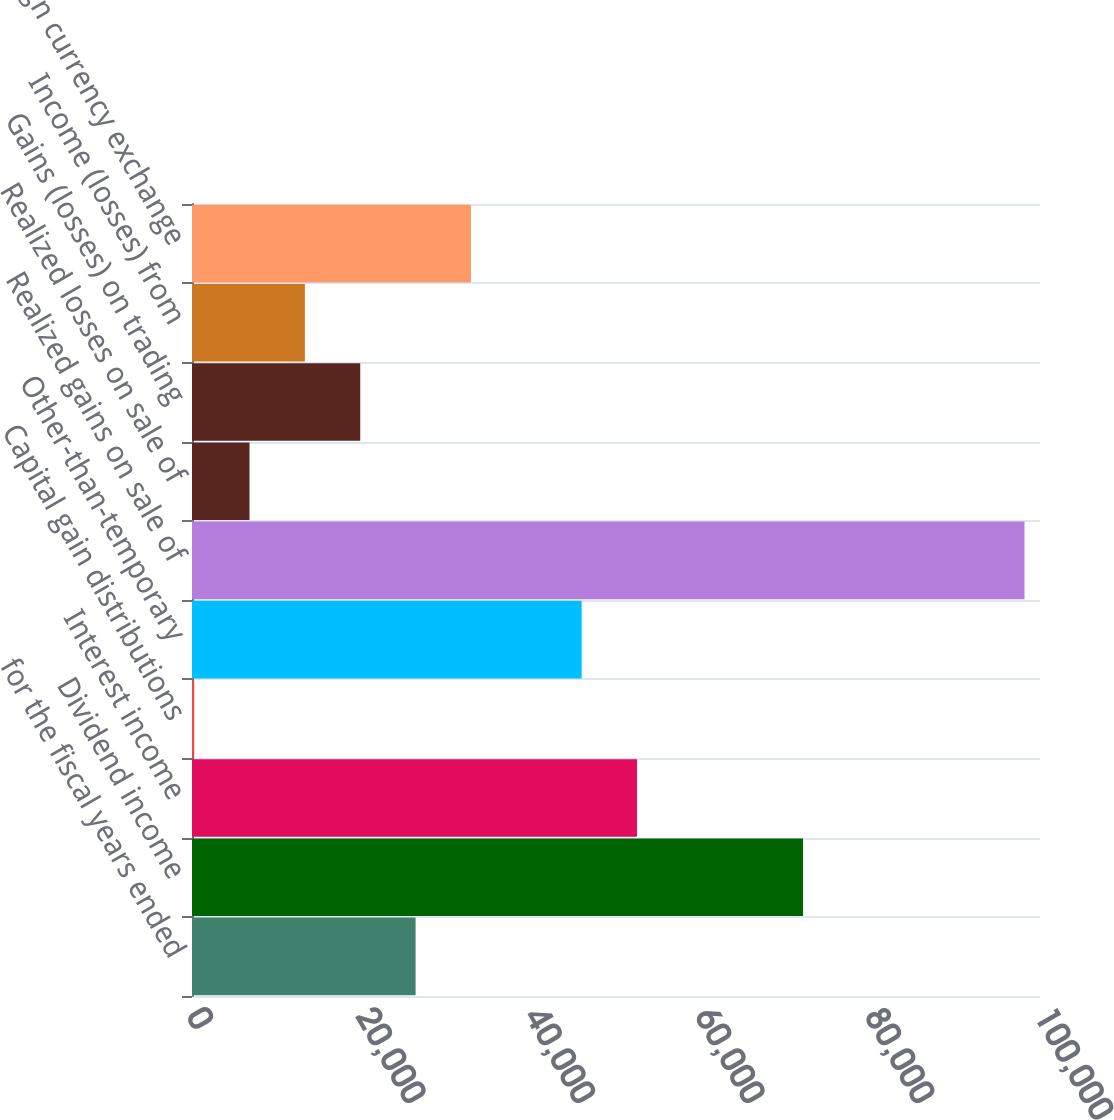<chart> <loc_0><loc_0><loc_500><loc_500><bar_chart><fcel>for the fiscal years ended<fcel>Dividend income<fcel>Interest income<fcel>Capital gain distributions<fcel>Other-than-temporary<fcel>Realized gains on sale of<fcel>Realized losses on sale of<fcel>Gains (losses) on trading<fcel>Income (losses) from<fcel>Foreign currency exchange<nl><fcel>26366.8<fcel>72060.7<fcel>52477.6<fcel>256<fcel>45949.9<fcel>98171.5<fcel>6783.7<fcel>19839.1<fcel>13311.4<fcel>32894.5<nl></chart> 